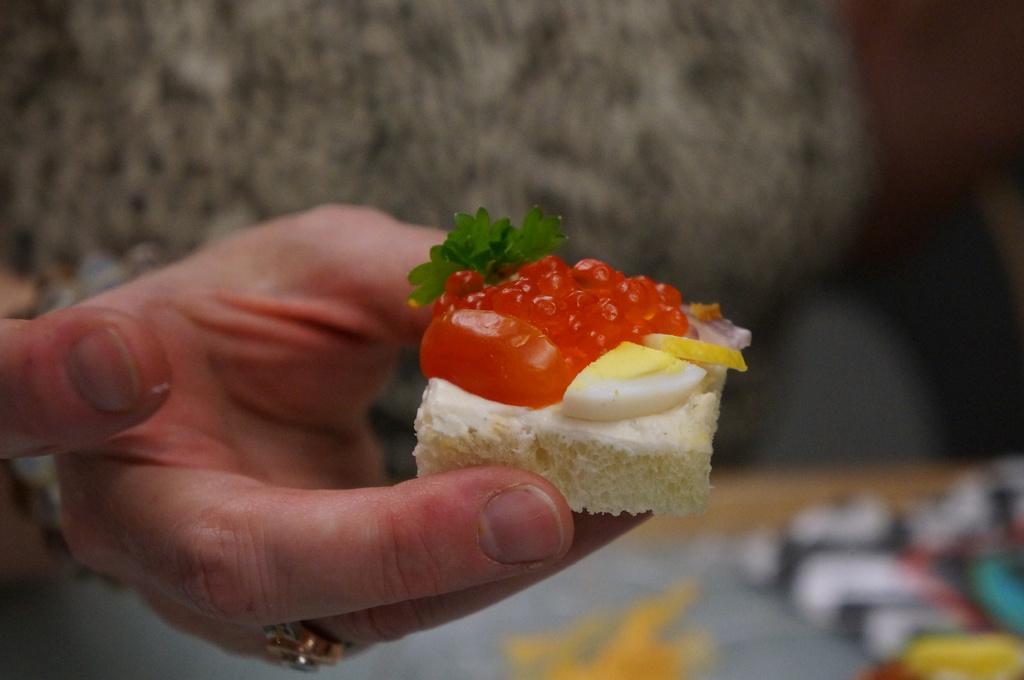Please provide a concise description of this image. In this image, we can see a hand holding a piece of cake. In the background, image is blurred. 